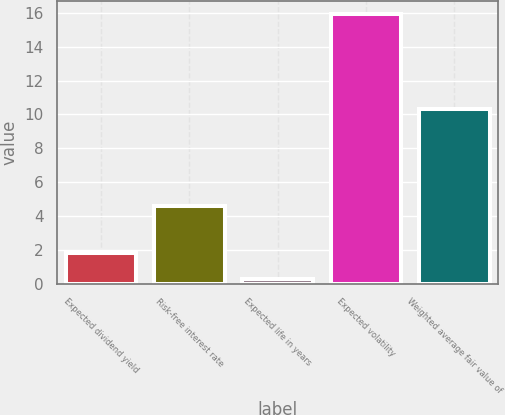<chart> <loc_0><loc_0><loc_500><loc_500><bar_chart><fcel>Expected dividend yield<fcel>Risk-free interest rate<fcel>Expected life in years<fcel>Expected volatility<fcel>Weighted average fair value of<nl><fcel>1.82<fcel>4.59<fcel>0.25<fcel>15.92<fcel>10.3<nl></chart> 